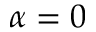<formula> <loc_0><loc_0><loc_500><loc_500>\alpha = 0</formula> 